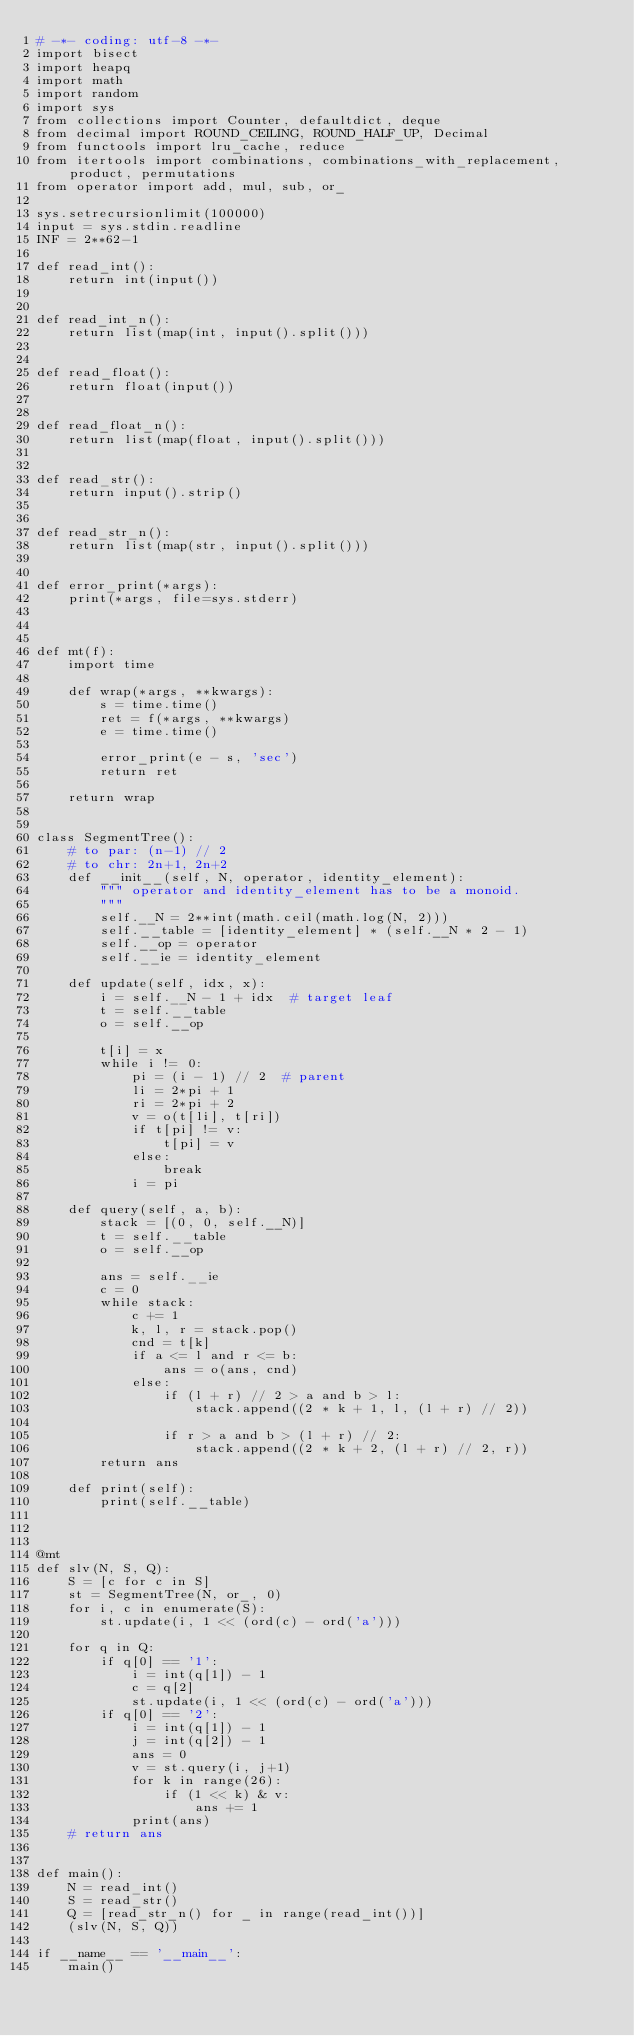Convert code to text. <code><loc_0><loc_0><loc_500><loc_500><_Python_># -*- coding: utf-8 -*-
import bisect
import heapq
import math
import random
import sys
from collections import Counter, defaultdict, deque
from decimal import ROUND_CEILING, ROUND_HALF_UP, Decimal
from functools import lru_cache, reduce
from itertools import combinations, combinations_with_replacement, product, permutations
from operator import add, mul, sub, or_

sys.setrecursionlimit(100000)
input = sys.stdin.readline
INF = 2**62-1

def read_int():
    return int(input())


def read_int_n():
    return list(map(int, input().split()))


def read_float():
    return float(input())


def read_float_n():
    return list(map(float, input().split()))


def read_str():
    return input().strip()


def read_str_n():
    return list(map(str, input().split()))


def error_print(*args):
    print(*args, file=sys.stderr)



def mt(f):
    import time

    def wrap(*args, **kwargs):
        s = time.time()
        ret = f(*args, **kwargs)
        e = time.time()

        error_print(e - s, 'sec')
        return ret

    return wrap


class SegmentTree():
    # to par: (n-1) // 2
    # to chr: 2n+1, 2n+2
    def __init__(self, N, operator, identity_element):
        """ operator and identity_element has to be a monoid.
        """
        self.__N = 2**int(math.ceil(math.log(N, 2)))
        self.__table = [identity_element] * (self.__N * 2 - 1)
        self.__op = operator
        self.__ie = identity_element

    def update(self, idx, x):
        i = self.__N - 1 + idx  # target leaf
        t = self.__table
        o = self.__op

        t[i] = x
        while i != 0:
            pi = (i - 1) // 2  # parent
            li = 2*pi + 1
            ri = 2*pi + 2
            v = o(t[li], t[ri])
            if t[pi] != v:
                t[pi] = v
            else:
                break
            i = pi

    def query(self, a, b):
        stack = [(0, 0, self.__N)]
        t = self.__table
        o = self.__op

        ans = self.__ie
        c = 0
        while stack:
            c += 1
            k, l, r = stack.pop()
            cnd = t[k]
            if a <= l and r <= b:
                ans = o(ans, cnd)
            else:
                if (l + r) // 2 > a and b > l:
                    stack.append((2 * k + 1, l, (l + r) // 2))

                if r > a and b > (l + r) // 2:
                    stack.append((2 * k + 2, (l + r) // 2, r))
        return ans

    def print(self):
        print(self.__table)



@mt
def slv(N, S, Q):
    S = [c for c in S]
    st = SegmentTree(N, or_, 0)
    for i, c in enumerate(S):
        st.update(i, 1 << (ord(c) - ord('a')))

    for q in Q:
        if q[0] == '1':
            i = int(q[1]) - 1
            c = q[2]
            st.update(i, 1 << (ord(c) - ord('a')))
        if q[0] == '2':
            i = int(q[1]) - 1
            j = int(q[2]) - 1
            ans = 0
            v = st.query(i, j+1)
            for k in range(26):
                if (1 << k) & v:
                    ans += 1
            print(ans)
    # return ans


def main():
    N = read_int()
    S = read_str()
    Q = [read_str_n() for _ in range(read_int())]
    (slv(N, S, Q))

if __name__ == '__main__':
    main()
</code> 